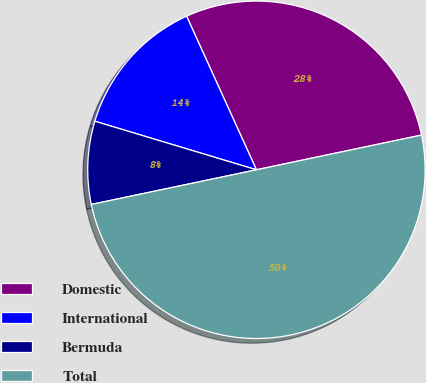<chart> <loc_0><loc_0><loc_500><loc_500><pie_chart><fcel>Domestic<fcel>International<fcel>Bermuda<fcel>Total<nl><fcel>28.49%<fcel>13.56%<fcel>7.94%<fcel>50.0%<nl></chart> 